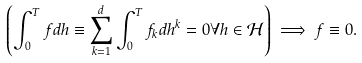Convert formula to latex. <formula><loc_0><loc_0><loc_500><loc_500>\left ( \int _ { 0 } ^ { T } f d h \equiv \sum _ { k = 1 } ^ { d } \int _ { 0 } ^ { T } f _ { k } d h ^ { k } = 0 \forall h \in \mathcal { H } \right ) \implies f \equiv 0 .</formula> 